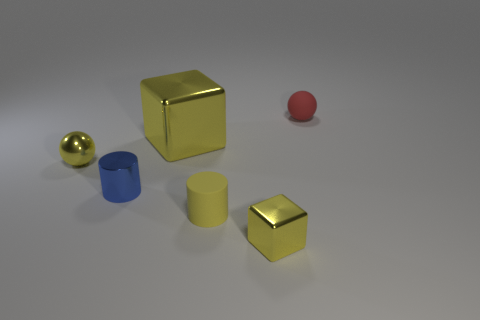What is the tiny yellow thing that is to the right of the cylinder that is to the right of the cylinder to the left of the small yellow cylinder made of?
Your answer should be very brief. Metal. There is a ball in front of the small red matte ball; is it the same color as the big object?
Your answer should be very brief. Yes. What number of yellow objects are big cubes or tiny objects?
Provide a succinct answer. 4. Do the yellow cylinder and the tiny yellow block have the same material?
Keep it short and to the point. No. The tiny thing that is to the left of the tiny yellow cube and to the right of the tiny blue object is made of what material?
Give a very brief answer. Rubber. The tiny matte thing that is in front of the rubber sphere is what color?
Make the answer very short. Yellow. Is the number of big yellow metal cubes right of the yellow metallic sphere greater than the number of gray metallic cubes?
Ensure brevity in your answer.  Yes. How many other things are the same size as the blue metal cylinder?
Provide a short and direct response. 4. How many matte spheres are behind the red rubber thing?
Make the answer very short. 0. Are there an equal number of small shiny cubes that are behind the yellow rubber thing and tiny spheres on the left side of the red object?
Your answer should be very brief. No. 